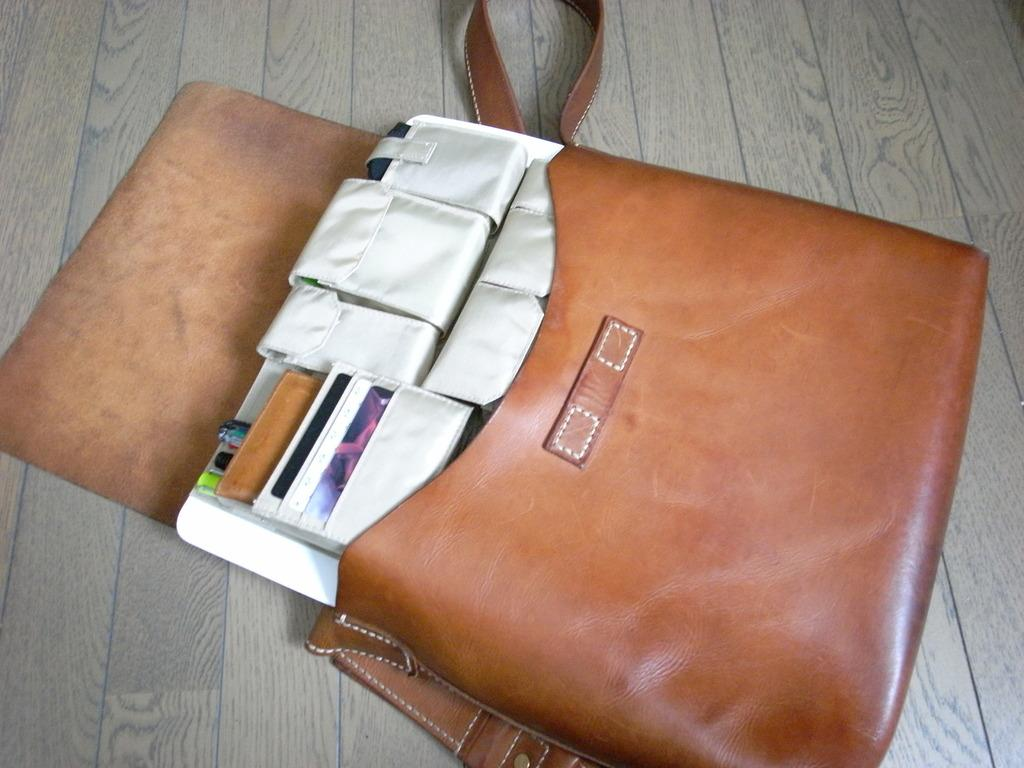What piece of furniture is present in the image? There is a table in the image. What is placed on the table? There is a brown bag on the table. What can be found inside the brown bag? The bag contains white objects. What type of rose is growing on the table in the image? There is no rose present in the image; the only items mentioned are a table, a brown bag, and white objects inside the bag. 